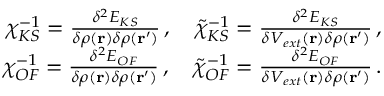<formula> <loc_0><loc_0><loc_500><loc_500>\begin{array} { r } { \chi _ { K S } ^ { - 1 } = \frac { \delta ^ { 2 } E _ { K S } } { \delta \rho ( r ) \delta \rho ( r ^ { \prime } ) } \, , \quad \tilde { \chi } _ { K S } ^ { - 1 } = \frac { \delta ^ { 2 } E _ { K S } } { \delta V _ { e x t } ( r ) \delta \rho ( r ^ { \prime } ) } \, , } \\ { \chi _ { O F } ^ { - 1 } = \frac { \delta ^ { 2 } E _ { O F } } { \delta \rho ( r ) \delta \rho ( r ^ { \prime } ) } \, , \quad \tilde { \chi } _ { O F } ^ { - 1 } = \frac { \delta ^ { 2 } E _ { O F } } { \delta V _ { e x t } ( r ) \delta \rho ( r ^ { \prime } ) } \, . } \end{array}</formula> 